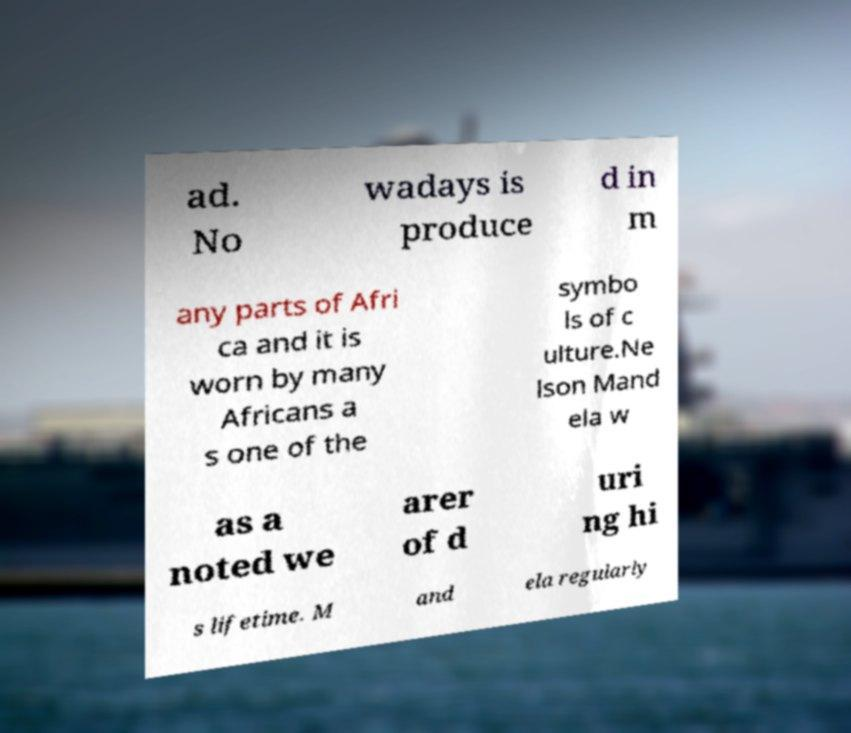There's text embedded in this image that I need extracted. Can you transcribe it verbatim? ad. No wadays is produce d in m any parts of Afri ca and it is worn by many Africans a s one of the symbo ls of c ulture.Ne lson Mand ela w as a noted we arer of d uri ng hi s lifetime. M and ela regularly 